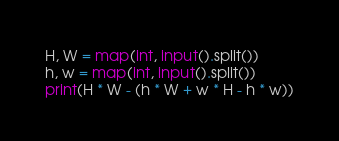Convert code to text. <code><loc_0><loc_0><loc_500><loc_500><_Python_>H, W = map(int, input().split())
h, w = map(int, input().split())
print(H * W - (h * W + w * H - h * w))</code> 